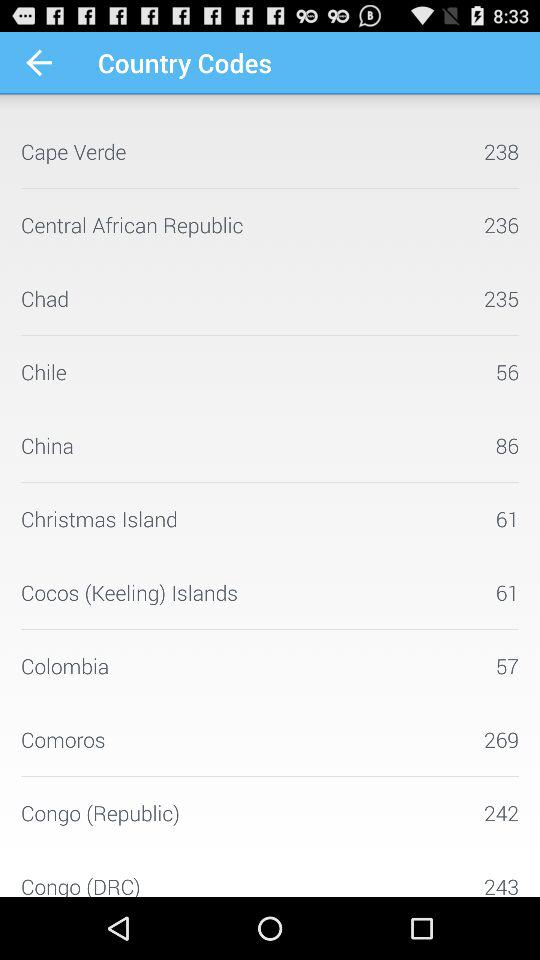What is the code for China? The code for China is 86. 